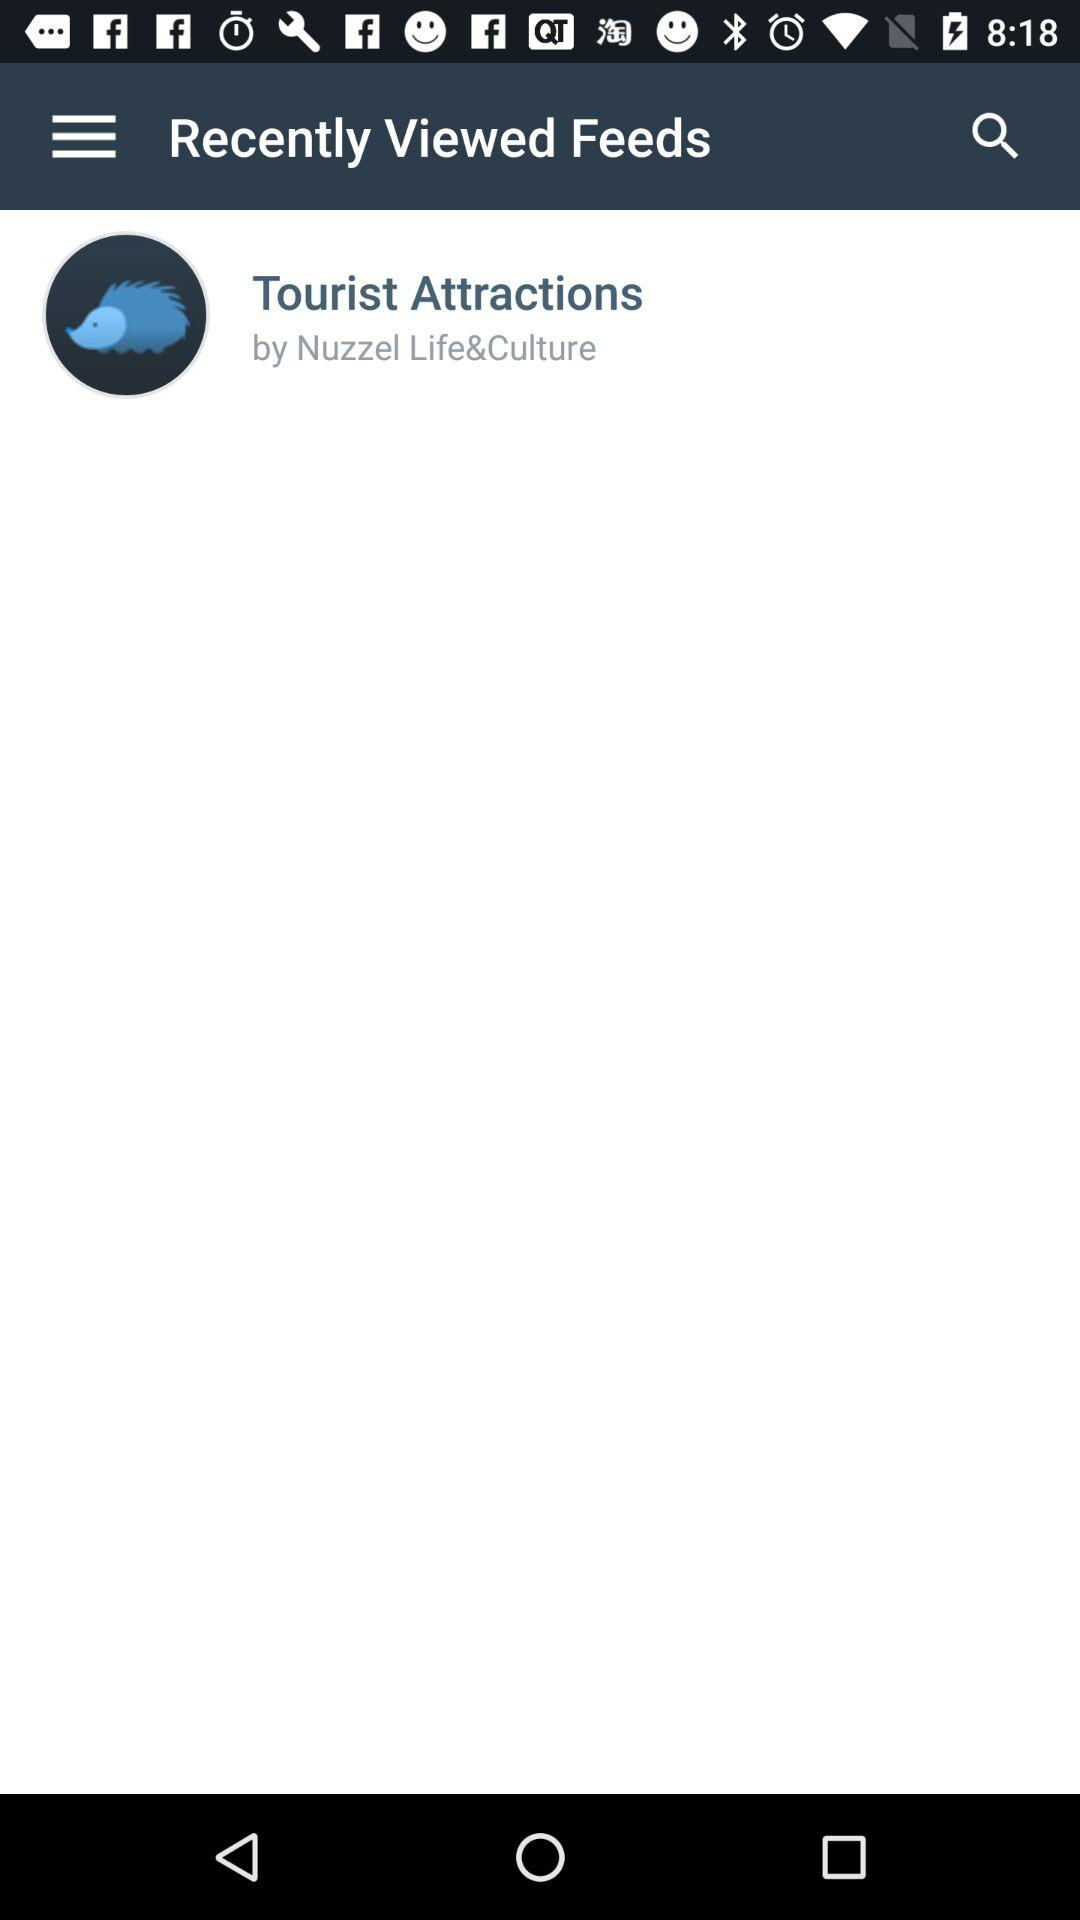What is the name of the author of "Tourist Attractions"? The name of the author of "Tourist Attractions" is "Nuzzel Life&Culture". 